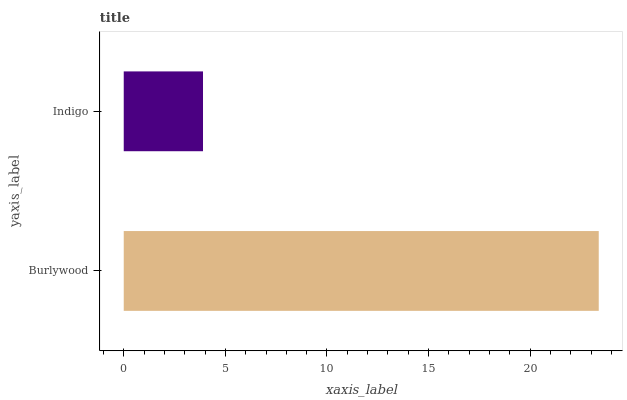Is Indigo the minimum?
Answer yes or no. Yes. Is Burlywood the maximum?
Answer yes or no. Yes. Is Indigo the maximum?
Answer yes or no. No. Is Burlywood greater than Indigo?
Answer yes or no. Yes. Is Indigo less than Burlywood?
Answer yes or no. Yes. Is Indigo greater than Burlywood?
Answer yes or no. No. Is Burlywood less than Indigo?
Answer yes or no. No. Is Burlywood the high median?
Answer yes or no. Yes. Is Indigo the low median?
Answer yes or no. Yes. Is Indigo the high median?
Answer yes or no. No. Is Burlywood the low median?
Answer yes or no. No. 